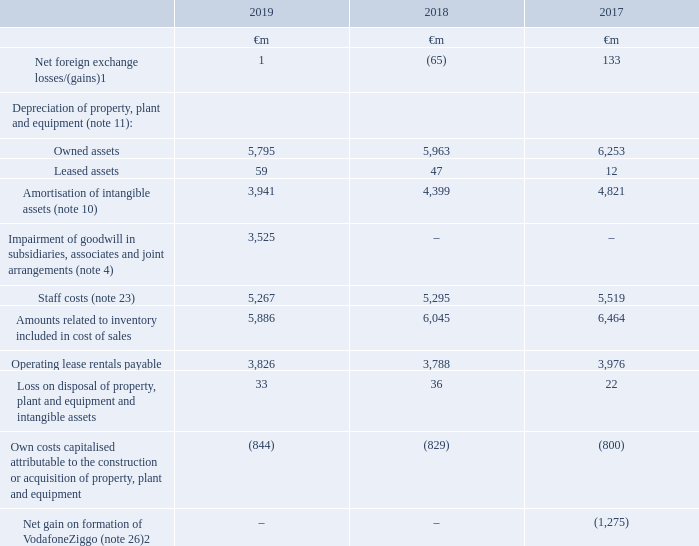3. Operating (loss)/profit
Detailed below are the key amounts recognised in arriving at our operating (loss)/profit
Notes: 1 The year ended 31 March 2019 included €nil (2018: €80 million credit, 2017: €127 million charge) reported in other income and expense in the consolidated income statement
2 Reported in other income and expense in the consolidated income statement.
Which financial years' information does this table show? 2017, 2018, 2019. What is the last day of Vodafone's 2019 financial year? 31 march. How much is the 2019 net foreign exchange losses?
Answer scale should be: million. 1. Between 2018 and 2019, which year had a greater amount of owned assets? 5,963>5,795
Answer: 2018. What is the average leased assets for 2018 and 2019?
Answer scale should be: million. (47+59)/2
Answer: 53. What is the difference between the average owned assets and the average leased assets in 2018 and 2019?
Answer scale should be: million. [(5,963+5,795)/2] - [(47+59)/2]
Answer: 5826. 